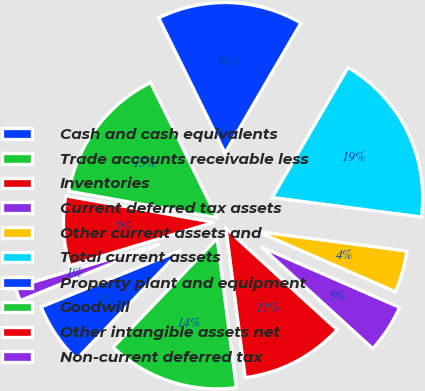Convert chart. <chart><loc_0><loc_0><loc_500><loc_500><pie_chart><fcel>Cash and cash equivalents<fcel>Trade accounts receivable less<fcel>Inventories<fcel>Current deferred tax assets<fcel>Other current assets and<fcel>Total current assets<fcel>Property plant and equipment<fcel>Goodwill<fcel>Other intangible assets net<fcel>Non-current deferred tax<nl><fcel>6.72%<fcel>14.18%<fcel>11.19%<fcel>5.22%<fcel>4.48%<fcel>18.66%<fcel>15.67%<fcel>14.92%<fcel>7.46%<fcel>1.49%<nl></chart> 